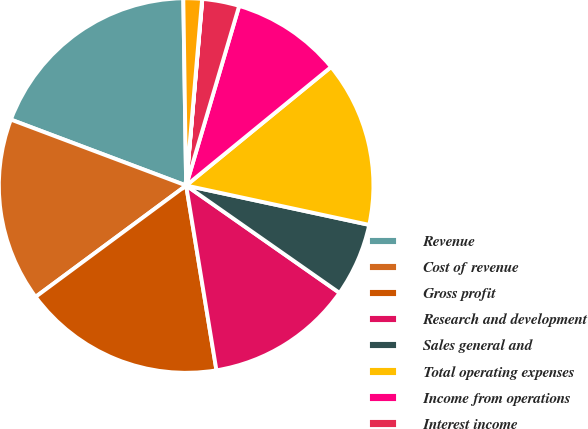Convert chart. <chart><loc_0><loc_0><loc_500><loc_500><pie_chart><fcel>Revenue<fcel>Cost of revenue<fcel>Gross profit<fcel>Research and development<fcel>Sales general and<fcel>Total operating expenses<fcel>Income from operations<fcel>Interest income<fcel>Interest expense<fcel>Other income (expense) net<nl><fcel>19.03%<fcel>15.86%<fcel>17.45%<fcel>12.69%<fcel>6.35%<fcel>14.28%<fcel>9.52%<fcel>3.19%<fcel>0.02%<fcel>1.6%<nl></chart> 